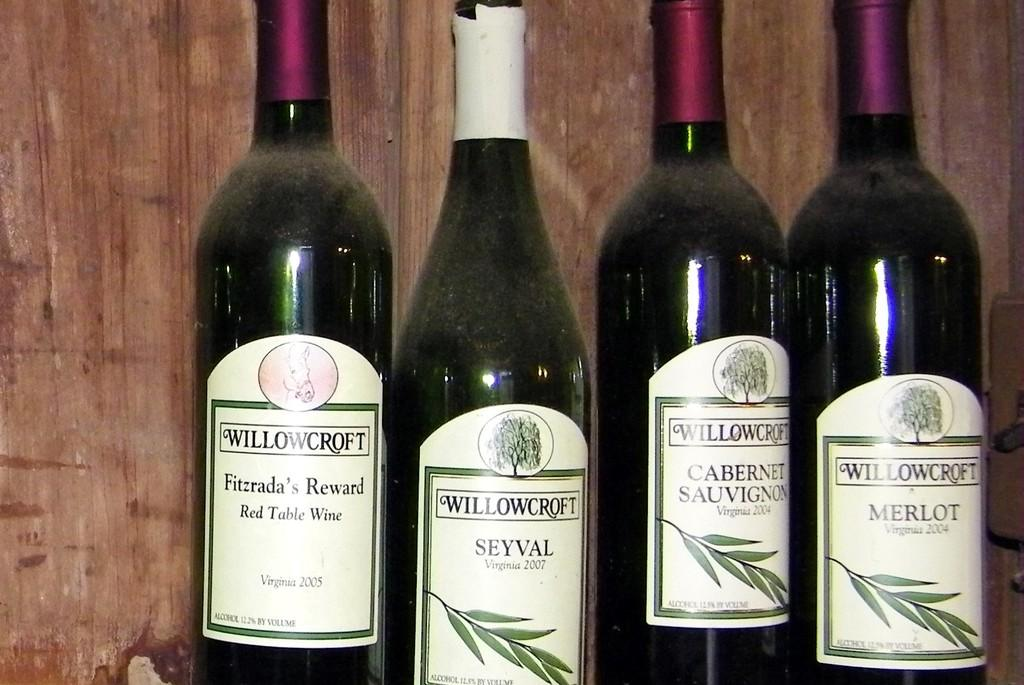<image>
Provide a brief description of the given image. Various bottles of WIllowcroft wine are lined up together. 